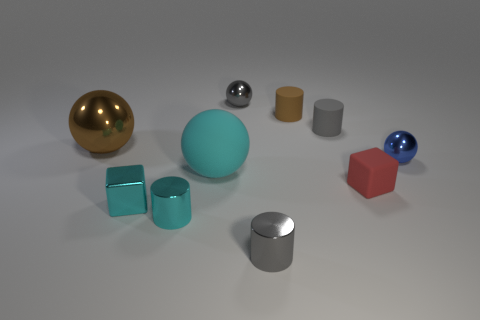Can you tell me the colors of the spherical objects? Certainly! There are three spherical objects, each a distinct color: gold, silver, and blue. 